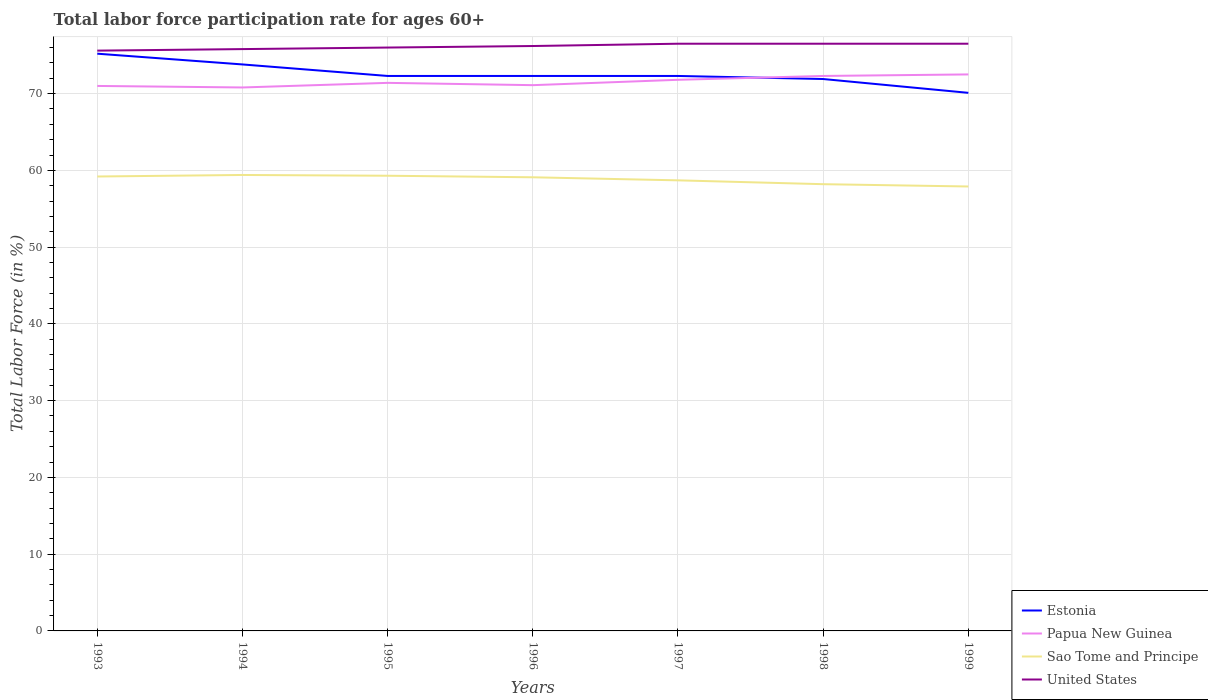How many different coloured lines are there?
Offer a terse response. 4. Is the number of lines equal to the number of legend labels?
Provide a short and direct response. Yes. Across all years, what is the maximum labor force participation rate in Sao Tome and Principe?
Keep it short and to the point. 57.9. In which year was the labor force participation rate in Estonia maximum?
Make the answer very short. 1999. Does the graph contain any zero values?
Keep it short and to the point. No. Does the graph contain grids?
Keep it short and to the point. Yes. How are the legend labels stacked?
Provide a succinct answer. Vertical. What is the title of the graph?
Keep it short and to the point. Total labor force participation rate for ages 60+. What is the label or title of the Y-axis?
Your response must be concise. Total Labor Force (in %). What is the Total Labor Force (in %) in Estonia in 1993?
Offer a terse response. 75.2. What is the Total Labor Force (in %) of Sao Tome and Principe in 1993?
Make the answer very short. 59.2. What is the Total Labor Force (in %) of United States in 1993?
Keep it short and to the point. 75.6. What is the Total Labor Force (in %) of Estonia in 1994?
Your response must be concise. 73.8. What is the Total Labor Force (in %) in Papua New Guinea in 1994?
Your answer should be very brief. 70.8. What is the Total Labor Force (in %) of Sao Tome and Principe in 1994?
Give a very brief answer. 59.4. What is the Total Labor Force (in %) of United States in 1994?
Offer a terse response. 75.8. What is the Total Labor Force (in %) in Estonia in 1995?
Make the answer very short. 72.3. What is the Total Labor Force (in %) of Papua New Guinea in 1995?
Your answer should be very brief. 71.4. What is the Total Labor Force (in %) in Sao Tome and Principe in 1995?
Ensure brevity in your answer.  59.3. What is the Total Labor Force (in %) in United States in 1995?
Provide a short and direct response. 76. What is the Total Labor Force (in %) of Estonia in 1996?
Make the answer very short. 72.3. What is the Total Labor Force (in %) in Papua New Guinea in 1996?
Provide a succinct answer. 71.1. What is the Total Labor Force (in %) of Sao Tome and Principe in 1996?
Ensure brevity in your answer.  59.1. What is the Total Labor Force (in %) in United States in 1996?
Offer a very short reply. 76.2. What is the Total Labor Force (in %) in Estonia in 1997?
Keep it short and to the point. 72.3. What is the Total Labor Force (in %) of Papua New Guinea in 1997?
Keep it short and to the point. 71.8. What is the Total Labor Force (in %) of Sao Tome and Principe in 1997?
Your response must be concise. 58.7. What is the Total Labor Force (in %) in United States in 1997?
Your answer should be very brief. 76.5. What is the Total Labor Force (in %) in Estonia in 1998?
Your answer should be compact. 71.9. What is the Total Labor Force (in %) in Papua New Guinea in 1998?
Give a very brief answer. 72.3. What is the Total Labor Force (in %) of Sao Tome and Principe in 1998?
Offer a terse response. 58.2. What is the Total Labor Force (in %) in United States in 1998?
Keep it short and to the point. 76.5. What is the Total Labor Force (in %) in Estonia in 1999?
Make the answer very short. 70.1. What is the Total Labor Force (in %) of Papua New Guinea in 1999?
Make the answer very short. 72.5. What is the Total Labor Force (in %) in Sao Tome and Principe in 1999?
Give a very brief answer. 57.9. What is the Total Labor Force (in %) in United States in 1999?
Your answer should be very brief. 76.5. Across all years, what is the maximum Total Labor Force (in %) in Estonia?
Ensure brevity in your answer.  75.2. Across all years, what is the maximum Total Labor Force (in %) of Papua New Guinea?
Keep it short and to the point. 72.5. Across all years, what is the maximum Total Labor Force (in %) of Sao Tome and Principe?
Your answer should be very brief. 59.4. Across all years, what is the maximum Total Labor Force (in %) of United States?
Offer a terse response. 76.5. Across all years, what is the minimum Total Labor Force (in %) of Estonia?
Provide a short and direct response. 70.1. Across all years, what is the minimum Total Labor Force (in %) of Papua New Guinea?
Give a very brief answer. 70.8. Across all years, what is the minimum Total Labor Force (in %) of Sao Tome and Principe?
Offer a terse response. 57.9. Across all years, what is the minimum Total Labor Force (in %) in United States?
Keep it short and to the point. 75.6. What is the total Total Labor Force (in %) of Estonia in the graph?
Provide a short and direct response. 507.9. What is the total Total Labor Force (in %) of Papua New Guinea in the graph?
Keep it short and to the point. 500.9. What is the total Total Labor Force (in %) of Sao Tome and Principe in the graph?
Provide a succinct answer. 411.8. What is the total Total Labor Force (in %) in United States in the graph?
Your answer should be very brief. 533.1. What is the difference between the Total Labor Force (in %) in Papua New Guinea in 1993 and that in 1994?
Make the answer very short. 0.2. What is the difference between the Total Labor Force (in %) in Papua New Guinea in 1993 and that in 1996?
Keep it short and to the point. -0.1. What is the difference between the Total Labor Force (in %) in Sao Tome and Principe in 1993 and that in 1996?
Your answer should be very brief. 0.1. What is the difference between the Total Labor Force (in %) of United States in 1993 and that in 1996?
Ensure brevity in your answer.  -0.6. What is the difference between the Total Labor Force (in %) in Sao Tome and Principe in 1993 and that in 1997?
Your answer should be very brief. 0.5. What is the difference between the Total Labor Force (in %) in United States in 1993 and that in 1997?
Your answer should be compact. -0.9. What is the difference between the Total Labor Force (in %) of Sao Tome and Principe in 1993 and that in 1998?
Offer a terse response. 1. What is the difference between the Total Labor Force (in %) of Estonia in 1993 and that in 1999?
Ensure brevity in your answer.  5.1. What is the difference between the Total Labor Force (in %) of Papua New Guinea in 1993 and that in 1999?
Offer a very short reply. -1.5. What is the difference between the Total Labor Force (in %) of United States in 1993 and that in 1999?
Make the answer very short. -0.9. What is the difference between the Total Labor Force (in %) of Estonia in 1994 and that in 1995?
Make the answer very short. 1.5. What is the difference between the Total Labor Force (in %) of Papua New Guinea in 1994 and that in 1995?
Offer a terse response. -0.6. What is the difference between the Total Labor Force (in %) in Sao Tome and Principe in 1994 and that in 1995?
Give a very brief answer. 0.1. What is the difference between the Total Labor Force (in %) of United States in 1994 and that in 1995?
Make the answer very short. -0.2. What is the difference between the Total Labor Force (in %) in Papua New Guinea in 1994 and that in 1996?
Give a very brief answer. -0.3. What is the difference between the Total Labor Force (in %) of Sao Tome and Principe in 1994 and that in 1997?
Offer a very short reply. 0.7. What is the difference between the Total Labor Force (in %) in United States in 1994 and that in 1997?
Your answer should be compact. -0.7. What is the difference between the Total Labor Force (in %) of Papua New Guinea in 1994 and that in 1998?
Keep it short and to the point. -1.5. What is the difference between the Total Labor Force (in %) of United States in 1994 and that in 1998?
Offer a very short reply. -0.7. What is the difference between the Total Labor Force (in %) in Estonia in 1994 and that in 1999?
Offer a very short reply. 3.7. What is the difference between the Total Labor Force (in %) of Papua New Guinea in 1994 and that in 1999?
Make the answer very short. -1.7. What is the difference between the Total Labor Force (in %) in Estonia in 1995 and that in 1996?
Keep it short and to the point. 0. What is the difference between the Total Labor Force (in %) in Papua New Guinea in 1995 and that in 1996?
Offer a terse response. 0.3. What is the difference between the Total Labor Force (in %) of United States in 1995 and that in 1996?
Ensure brevity in your answer.  -0.2. What is the difference between the Total Labor Force (in %) in Estonia in 1995 and that in 1997?
Your response must be concise. 0. What is the difference between the Total Labor Force (in %) in Sao Tome and Principe in 1995 and that in 1997?
Make the answer very short. 0.6. What is the difference between the Total Labor Force (in %) in Papua New Guinea in 1995 and that in 1998?
Your answer should be compact. -0.9. What is the difference between the Total Labor Force (in %) of Sao Tome and Principe in 1995 and that in 1998?
Give a very brief answer. 1.1. What is the difference between the Total Labor Force (in %) of United States in 1995 and that in 1998?
Make the answer very short. -0.5. What is the difference between the Total Labor Force (in %) of Papua New Guinea in 1995 and that in 1999?
Your answer should be compact. -1.1. What is the difference between the Total Labor Force (in %) of Sao Tome and Principe in 1995 and that in 1999?
Keep it short and to the point. 1.4. What is the difference between the Total Labor Force (in %) in Estonia in 1996 and that in 1997?
Give a very brief answer. 0. What is the difference between the Total Labor Force (in %) of United States in 1996 and that in 1997?
Provide a short and direct response. -0.3. What is the difference between the Total Labor Force (in %) of Sao Tome and Principe in 1996 and that in 1998?
Your answer should be compact. 0.9. What is the difference between the Total Labor Force (in %) in United States in 1996 and that in 1998?
Offer a terse response. -0.3. What is the difference between the Total Labor Force (in %) in Estonia in 1996 and that in 1999?
Provide a short and direct response. 2.2. What is the difference between the Total Labor Force (in %) in Estonia in 1997 and that in 1998?
Provide a short and direct response. 0.4. What is the difference between the Total Labor Force (in %) of Papua New Guinea in 1997 and that in 1998?
Offer a terse response. -0.5. What is the difference between the Total Labor Force (in %) of Estonia in 1997 and that in 1999?
Provide a succinct answer. 2.2. What is the difference between the Total Labor Force (in %) of Papua New Guinea in 1997 and that in 1999?
Offer a terse response. -0.7. What is the difference between the Total Labor Force (in %) in Estonia in 1998 and that in 1999?
Your response must be concise. 1.8. What is the difference between the Total Labor Force (in %) in Papua New Guinea in 1998 and that in 1999?
Your response must be concise. -0.2. What is the difference between the Total Labor Force (in %) in United States in 1998 and that in 1999?
Provide a succinct answer. 0. What is the difference between the Total Labor Force (in %) of Papua New Guinea in 1993 and the Total Labor Force (in %) of Sao Tome and Principe in 1994?
Provide a succinct answer. 11.6. What is the difference between the Total Labor Force (in %) of Papua New Guinea in 1993 and the Total Labor Force (in %) of United States in 1994?
Provide a short and direct response. -4.8. What is the difference between the Total Labor Force (in %) in Sao Tome and Principe in 1993 and the Total Labor Force (in %) in United States in 1994?
Make the answer very short. -16.6. What is the difference between the Total Labor Force (in %) of Estonia in 1993 and the Total Labor Force (in %) of Papua New Guinea in 1995?
Your answer should be very brief. 3.8. What is the difference between the Total Labor Force (in %) of Estonia in 1993 and the Total Labor Force (in %) of United States in 1995?
Keep it short and to the point. -0.8. What is the difference between the Total Labor Force (in %) of Papua New Guinea in 1993 and the Total Labor Force (in %) of Sao Tome and Principe in 1995?
Give a very brief answer. 11.7. What is the difference between the Total Labor Force (in %) of Sao Tome and Principe in 1993 and the Total Labor Force (in %) of United States in 1995?
Provide a succinct answer. -16.8. What is the difference between the Total Labor Force (in %) in Estonia in 1993 and the Total Labor Force (in %) in Papua New Guinea in 1996?
Your response must be concise. 4.1. What is the difference between the Total Labor Force (in %) of Estonia in 1993 and the Total Labor Force (in %) of Sao Tome and Principe in 1996?
Offer a terse response. 16.1. What is the difference between the Total Labor Force (in %) in Estonia in 1993 and the Total Labor Force (in %) in United States in 1996?
Make the answer very short. -1. What is the difference between the Total Labor Force (in %) of Papua New Guinea in 1993 and the Total Labor Force (in %) of United States in 1996?
Your answer should be compact. -5.2. What is the difference between the Total Labor Force (in %) of Estonia in 1993 and the Total Labor Force (in %) of Papua New Guinea in 1997?
Make the answer very short. 3.4. What is the difference between the Total Labor Force (in %) of Estonia in 1993 and the Total Labor Force (in %) of Sao Tome and Principe in 1997?
Give a very brief answer. 16.5. What is the difference between the Total Labor Force (in %) of Sao Tome and Principe in 1993 and the Total Labor Force (in %) of United States in 1997?
Your answer should be compact. -17.3. What is the difference between the Total Labor Force (in %) in Estonia in 1993 and the Total Labor Force (in %) in Papua New Guinea in 1998?
Provide a succinct answer. 2.9. What is the difference between the Total Labor Force (in %) of Estonia in 1993 and the Total Labor Force (in %) of Sao Tome and Principe in 1998?
Provide a succinct answer. 17. What is the difference between the Total Labor Force (in %) in Estonia in 1993 and the Total Labor Force (in %) in United States in 1998?
Provide a succinct answer. -1.3. What is the difference between the Total Labor Force (in %) in Papua New Guinea in 1993 and the Total Labor Force (in %) in United States in 1998?
Keep it short and to the point. -5.5. What is the difference between the Total Labor Force (in %) in Sao Tome and Principe in 1993 and the Total Labor Force (in %) in United States in 1998?
Your answer should be compact. -17.3. What is the difference between the Total Labor Force (in %) in Estonia in 1993 and the Total Labor Force (in %) in Papua New Guinea in 1999?
Your answer should be compact. 2.7. What is the difference between the Total Labor Force (in %) of Papua New Guinea in 1993 and the Total Labor Force (in %) of United States in 1999?
Give a very brief answer. -5.5. What is the difference between the Total Labor Force (in %) in Sao Tome and Principe in 1993 and the Total Labor Force (in %) in United States in 1999?
Offer a terse response. -17.3. What is the difference between the Total Labor Force (in %) in Estonia in 1994 and the Total Labor Force (in %) in Papua New Guinea in 1995?
Provide a succinct answer. 2.4. What is the difference between the Total Labor Force (in %) of Estonia in 1994 and the Total Labor Force (in %) of Sao Tome and Principe in 1995?
Provide a short and direct response. 14.5. What is the difference between the Total Labor Force (in %) in Papua New Guinea in 1994 and the Total Labor Force (in %) in United States in 1995?
Provide a succinct answer. -5.2. What is the difference between the Total Labor Force (in %) in Sao Tome and Principe in 1994 and the Total Labor Force (in %) in United States in 1995?
Your answer should be compact. -16.6. What is the difference between the Total Labor Force (in %) in Estonia in 1994 and the Total Labor Force (in %) in Sao Tome and Principe in 1996?
Make the answer very short. 14.7. What is the difference between the Total Labor Force (in %) of Sao Tome and Principe in 1994 and the Total Labor Force (in %) of United States in 1996?
Give a very brief answer. -16.8. What is the difference between the Total Labor Force (in %) of Estonia in 1994 and the Total Labor Force (in %) of United States in 1997?
Provide a succinct answer. -2.7. What is the difference between the Total Labor Force (in %) in Papua New Guinea in 1994 and the Total Labor Force (in %) in United States in 1997?
Provide a succinct answer. -5.7. What is the difference between the Total Labor Force (in %) of Sao Tome and Principe in 1994 and the Total Labor Force (in %) of United States in 1997?
Ensure brevity in your answer.  -17.1. What is the difference between the Total Labor Force (in %) in Estonia in 1994 and the Total Labor Force (in %) in United States in 1998?
Offer a terse response. -2.7. What is the difference between the Total Labor Force (in %) in Papua New Guinea in 1994 and the Total Labor Force (in %) in United States in 1998?
Your answer should be very brief. -5.7. What is the difference between the Total Labor Force (in %) in Sao Tome and Principe in 1994 and the Total Labor Force (in %) in United States in 1998?
Your answer should be very brief. -17.1. What is the difference between the Total Labor Force (in %) in Estonia in 1994 and the Total Labor Force (in %) in Papua New Guinea in 1999?
Provide a short and direct response. 1.3. What is the difference between the Total Labor Force (in %) of Estonia in 1994 and the Total Labor Force (in %) of United States in 1999?
Ensure brevity in your answer.  -2.7. What is the difference between the Total Labor Force (in %) in Papua New Guinea in 1994 and the Total Labor Force (in %) in United States in 1999?
Your answer should be very brief. -5.7. What is the difference between the Total Labor Force (in %) of Sao Tome and Principe in 1994 and the Total Labor Force (in %) of United States in 1999?
Offer a terse response. -17.1. What is the difference between the Total Labor Force (in %) in Estonia in 1995 and the Total Labor Force (in %) in Papua New Guinea in 1996?
Offer a very short reply. 1.2. What is the difference between the Total Labor Force (in %) of Estonia in 1995 and the Total Labor Force (in %) of Sao Tome and Principe in 1996?
Ensure brevity in your answer.  13.2. What is the difference between the Total Labor Force (in %) of Estonia in 1995 and the Total Labor Force (in %) of United States in 1996?
Your answer should be compact. -3.9. What is the difference between the Total Labor Force (in %) in Sao Tome and Principe in 1995 and the Total Labor Force (in %) in United States in 1996?
Provide a short and direct response. -16.9. What is the difference between the Total Labor Force (in %) of Estonia in 1995 and the Total Labor Force (in %) of Papua New Guinea in 1997?
Provide a short and direct response. 0.5. What is the difference between the Total Labor Force (in %) in Papua New Guinea in 1995 and the Total Labor Force (in %) in Sao Tome and Principe in 1997?
Give a very brief answer. 12.7. What is the difference between the Total Labor Force (in %) of Sao Tome and Principe in 1995 and the Total Labor Force (in %) of United States in 1997?
Offer a terse response. -17.2. What is the difference between the Total Labor Force (in %) in Estonia in 1995 and the Total Labor Force (in %) in Papua New Guinea in 1998?
Your response must be concise. 0. What is the difference between the Total Labor Force (in %) in Estonia in 1995 and the Total Labor Force (in %) in United States in 1998?
Keep it short and to the point. -4.2. What is the difference between the Total Labor Force (in %) in Papua New Guinea in 1995 and the Total Labor Force (in %) in Sao Tome and Principe in 1998?
Offer a very short reply. 13.2. What is the difference between the Total Labor Force (in %) of Sao Tome and Principe in 1995 and the Total Labor Force (in %) of United States in 1998?
Your response must be concise. -17.2. What is the difference between the Total Labor Force (in %) in Estonia in 1995 and the Total Labor Force (in %) in Sao Tome and Principe in 1999?
Keep it short and to the point. 14.4. What is the difference between the Total Labor Force (in %) of Papua New Guinea in 1995 and the Total Labor Force (in %) of Sao Tome and Principe in 1999?
Ensure brevity in your answer.  13.5. What is the difference between the Total Labor Force (in %) in Sao Tome and Principe in 1995 and the Total Labor Force (in %) in United States in 1999?
Provide a short and direct response. -17.2. What is the difference between the Total Labor Force (in %) of Estonia in 1996 and the Total Labor Force (in %) of Sao Tome and Principe in 1997?
Your answer should be very brief. 13.6. What is the difference between the Total Labor Force (in %) in Papua New Guinea in 1996 and the Total Labor Force (in %) in Sao Tome and Principe in 1997?
Give a very brief answer. 12.4. What is the difference between the Total Labor Force (in %) of Sao Tome and Principe in 1996 and the Total Labor Force (in %) of United States in 1997?
Ensure brevity in your answer.  -17.4. What is the difference between the Total Labor Force (in %) in Estonia in 1996 and the Total Labor Force (in %) in Papua New Guinea in 1998?
Offer a terse response. 0. What is the difference between the Total Labor Force (in %) of Estonia in 1996 and the Total Labor Force (in %) of Sao Tome and Principe in 1998?
Give a very brief answer. 14.1. What is the difference between the Total Labor Force (in %) of Papua New Guinea in 1996 and the Total Labor Force (in %) of Sao Tome and Principe in 1998?
Offer a terse response. 12.9. What is the difference between the Total Labor Force (in %) of Sao Tome and Principe in 1996 and the Total Labor Force (in %) of United States in 1998?
Keep it short and to the point. -17.4. What is the difference between the Total Labor Force (in %) of Papua New Guinea in 1996 and the Total Labor Force (in %) of United States in 1999?
Make the answer very short. -5.4. What is the difference between the Total Labor Force (in %) of Sao Tome and Principe in 1996 and the Total Labor Force (in %) of United States in 1999?
Make the answer very short. -17.4. What is the difference between the Total Labor Force (in %) in Estonia in 1997 and the Total Labor Force (in %) in Sao Tome and Principe in 1998?
Provide a succinct answer. 14.1. What is the difference between the Total Labor Force (in %) of Sao Tome and Principe in 1997 and the Total Labor Force (in %) of United States in 1998?
Provide a short and direct response. -17.8. What is the difference between the Total Labor Force (in %) in Estonia in 1997 and the Total Labor Force (in %) in Sao Tome and Principe in 1999?
Your answer should be compact. 14.4. What is the difference between the Total Labor Force (in %) of Estonia in 1997 and the Total Labor Force (in %) of United States in 1999?
Offer a very short reply. -4.2. What is the difference between the Total Labor Force (in %) in Papua New Guinea in 1997 and the Total Labor Force (in %) in Sao Tome and Principe in 1999?
Ensure brevity in your answer.  13.9. What is the difference between the Total Labor Force (in %) in Papua New Guinea in 1997 and the Total Labor Force (in %) in United States in 1999?
Your response must be concise. -4.7. What is the difference between the Total Labor Force (in %) of Sao Tome and Principe in 1997 and the Total Labor Force (in %) of United States in 1999?
Your answer should be very brief. -17.8. What is the difference between the Total Labor Force (in %) of Estonia in 1998 and the Total Labor Force (in %) of Papua New Guinea in 1999?
Offer a very short reply. -0.6. What is the difference between the Total Labor Force (in %) of Papua New Guinea in 1998 and the Total Labor Force (in %) of Sao Tome and Principe in 1999?
Your response must be concise. 14.4. What is the difference between the Total Labor Force (in %) in Papua New Guinea in 1998 and the Total Labor Force (in %) in United States in 1999?
Offer a very short reply. -4.2. What is the difference between the Total Labor Force (in %) in Sao Tome and Principe in 1998 and the Total Labor Force (in %) in United States in 1999?
Provide a short and direct response. -18.3. What is the average Total Labor Force (in %) in Estonia per year?
Provide a succinct answer. 72.56. What is the average Total Labor Force (in %) in Papua New Guinea per year?
Provide a succinct answer. 71.56. What is the average Total Labor Force (in %) in Sao Tome and Principe per year?
Make the answer very short. 58.83. What is the average Total Labor Force (in %) in United States per year?
Keep it short and to the point. 76.16. In the year 1993, what is the difference between the Total Labor Force (in %) in Estonia and Total Labor Force (in %) in Sao Tome and Principe?
Provide a short and direct response. 16. In the year 1993, what is the difference between the Total Labor Force (in %) in Papua New Guinea and Total Labor Force (in %) in Sao Tome and Principe?
Offer a terse response. 11.8. In the year 1993, what is the difference between the Total Labor Force (in %) in Papua New Guinea and Total Labor Force (in %) in United States?
Your answer should be very brief. -4.6. In the year 1993, what is the difference between the Total Labor Force (in %) in Sao Tome and Principe and Total Labor Force (in %) in United States?
Give a very brief answer. -16.4. In the year 1994, what is the difference between the Total Labor Force (in %) in Estonia and Total Labor Force (in %) in Papua New Guinea?
Make the answer very short. 3. In the year 1994, what is the difference between the Total Labor Force (in %) of Papua New Guinea and Total Labor Force (in %) of Sao Tome and Principe?
Keep it short and to the point. 11.4. In the year 1994, what is the difference between the Total Labor Force (in %) in Sao Tome and Principe and Total Labor Force (in %) in United States?
Your answer should be compact. -16.4. In the year 1995, what is the difference between the Total Labor Force (in %) of Papua New Guinea and Total Labor Force (in %) of United States?
Make the answer very short. -4.6. In the year 1995, what is the difference between the Total Labor Force (in %) of Sao Tome and Principe and Total Labor Force (in %) of United States?
Give a very brief answer. -16.7. In the year 1996, what is the difference between the Total Labor Force (in %) of Estonia and Total Labor Force (in %) of Papua New Guinea?
Offer a terse response. 1.2. In the year 1996, what is the difference between the Total Labor Force (in %) of Estonia and Total Labor Force (in %) of United States?
Provide a succinct answer. -3.9. In the year 1996, what is the difference between the Total Labor Force (in %) in Papua New Guinea and Total Labor Force (in %) in Sao Tome and Principe?
Make the answer very short. 12. In the year 1996, what is the difference between the Total Labor Force (in %) in Sao Tome and Principe and Total Labor Force (in %) in United States?
Offer a very short reply. -17.1. In the year 1997, what is the difference between the Total Labor Force (in %) of Estonia and Total Labor Force (in %) of Papua New Guinea?
Your answer should be very brief. 0.5. In the year 1997, what is the difference between the Total Labor Force (in %) of Estonia and Total Labor Force (in %) of Sao Tome and Principe?
Your response must be concise. 13.6. In the year 1997, what is the difference between the Total Labor Force (in %) of Estonia and Total Labor Force (in %) of United States?
Offer a very short reply. -4.2. In the year 1997, what is the difference between the Total Labor Force (in %) of Papua New Guinea and Total Labor Force (in %) of United States?
Offer a very short reply. -4.7. In the year 1997, what is the difference between the Total Labor Force (in %) of Sao Tome and Principe and Total Labor Force (in %) of United States?
Give a very brief answer. -17.8. In the year 1998, what is the difference between the Total Labor Force (in %) of Estonia and Total Labor Force (in %) of Papua New Guinea?
Ensure brevity in your answer.  -0.4. In the year 1998, what is the difference between the Total Labor Force (in %) of Estonia and Total Labor Force (in %) of Sao Tome and Principe?
Offer a very short reply. 13.7. In the year 1998, what is the difference between the Total Labor Force (in %) of Papua New Guinea and Total Labor Force (in %) of Sao Tome and Principe?
Give a very brief answer. 14.1. In the year 1998, what is the difference between the Total Labor Force (in %) of Papua New Guinea and Total Labor Force (in %) of United States?
Give a very brief answer. -4.2. In the year 1998, what is the difference between the Total Labor Force (in %) of Sao Tome and Principe and Total Labor Force (in %) of United States?
Offer a terse response. -18.3. In the year 1999, what is the difference between the Total Labor Force (in %) of Estonia and Total Labor Force (in %) of Sao Tome and Principe?
Offer a very short reply. 12.2. In the year 1999, what is the difference between the Total Labor Force (in %) of Papua New Guinea and Total Labor Force (in %) of Sao Tome and Principe?
Your answer should be very brief. 14.6. In the year 1999, what is the difference between the Total Labor Force (in %) of Sao Tome and Principe and Total Labor Force (in %) of United States?
Provide a succinct answer. -18.6. What is the ratio of the Total Labor Force (in %) of Papua New Guinea in 1993 to that in 1994?
Offer a terse response. 1. What is the ratio of the Total Labor Force (in %) of Sao Tome and Principe in 1993 to that in 1994?
Keep it short and to the point. 1. What is the ratio of the Total Labor Force (in %) of United States in 1993 to that in 1994?
Provide a short and direct response. 1. What is the ratio of the Total Labor Force (in %) in Estonia in 1993 to that in 1995?
Your answer should be compact. 1.04. What is the ratio of the Total Labor Force (in %) in Sao Tome and Principe in 1993 to that in 1995?
Give a very brief answer. 1. What is the ratio of the Total Labor Force (in %) in Estonia in 1993 to that in 1996?
Offer a terse response. 1.04. What is the ratio of the Total Labor Force (in %) of Papua New Guinea in 1993 to that in 1996?
Offer a terse response. 1. What is the ratio of the Total Labor Force (in %) in Estonia in 1993 to that in 1997?
Provide a succinct answer. 1.04. What is the ratio of the Total Labor Force (in %) of Papua New Guinea in 1993 to that in 1997?
Your answer should be very brief. 0.99. What is the ratio of the Total Labor Force (in %) of Sao Tome and Principe in 1993 to that in 1997?
Provide a short and direct response. 1.01. What is the ratio of the Total Labor Force (in %) of United States in 1993 to that in 1997?
Offer a terse response. 0.99. What is the ratio of the Total Labor Force (in %) of Estonia in 1993 to that in 1998?
Your answer should be compact. 1.05. What is the ratio of the Total Labor Force (in %) of Papua New Guinea in 1993 to that in 1998?
Offer a very short reply. 0.98. What is the ratio of the Total Labor Force (in %) of Sao Tome and Principe in 1993 to that in 1998?
Provide a succinct answer. 1.02. What is the ratio of the Total Labor Force (in %) of Estonia in 1993 to that in 1999?
Give a very brief answer. 1.07. What is the ratio of the Total Labor Force (in %) of Papua New Guinea in 1993 to that in 1999?
Offer a very short reply. 0.98. What is the ratio of the Total Labor Force (in %) in Sao Tome and Principe in 1993 to that in 1999?
Offer a terse response. 1.02. What is the ratio of the Total Labor Force (in %) in United States in 1993 to that in 1999?
Make the answer very short. 0.99. What is the ratio of the Total Labor Force (in %) of Estonia in 1994 to that in 1995?
Keep it short and to the point. 1.02. What is the ratio of the Total Labor Force (in %) in Estonia in 1994 to that in 1996?
Make the answer very short. 1.02. What is the ratio of the Total Labor Force (in %) in Papua New Guinea in 1994 to that in 1996?
Make the answer very short. 1. What is the ratio of the Total Labor Force (in %) in United States in 1994 to that in 1996?
Make the answer very short. 0.99. What is the ratio of the Total Labor Force (in %) of Estonia in 1994 to that in 1997?
Give a very brief answer. 1.02. What is the ratio of the Total Labor Force (in %) in Papua New Guinea in 1994 to that in 1997?
Your answer should be very brief. 0.99. What is the ratio of the Total Labor Force (in %) in Sao Tome and Principe in 1994 to that in 1997?
Ensure brevity in your answer.  1.01. What is the ratio of the Total Labor Force (in %) of Estonia in 1994 to that in 1998?
Your response must be concise. 1.03. What is the ratio of the Total Labor Force (in %) of Papua New Guinea in 1994 to that in 1998?
Provide a short and direct response. 0.98. What is the ratio of the Total Labor Force (in %) of Sao Tome and Principe in 1994 to that in 1998?
Your answer should be very brief. 1.02. What is the ratio of the Total Labor Force (in %) in United States in 1994 to that in 1998?
Offer a very short reply. 0.99. What is the ratio of the Total Labor Force (in %) of Estonia in 1994 to that in 1999?
Keep it short and to the point. 1.05. What is the ratio of the Total Labor Force (in %) of Papua New Guinea in 1994 to that in 1999?
Offer a terse response. 0.98. What is the ratio of the Total Labor Force (in %) of Sao Tome and Principe in 1994 to that in 1999?
Your response must be concise. 1.03. What is the ratio of the Total Labor Force (in %) of United States in 1994 to that in 1999?
Your answer should be compact. 0.99. What is the ratio of the Total Labor Force (in %) of Estonia in 1995 to that in 1996?
Ensure brevity in your answer.  1. What is the ratio of the Total Labor Force (in %) of Papua New Guinea in 1995 to that in 1996?
Keep it short and to the point. 1. What is the ratio of the Total Labor Force (in %) in United States in 1995 to that in 1996?
Your response must be concise. 1. What is the ratio of the Total Labor Force (in %) in Estonia in 1995 to that in 1997?
Offer a very short reply. 1. What is the ratio of the Total Labor Force (in %) of Papua New Guinea in 1995 to that in 1997?
Your answer should be very brief. 0.99. What is the ratio of the Total Labor Force (in %) of Sao Tome and Principe in 1995 to that in 1997?
Provide a succinct answer. 1.01. What is the ratio of the Total Labor Force (in %) of Estonia in 1995 to that in 1998?
Provide a short and direct response. 1.01. What is the ratio of the Total Labor Force (in %) of Papua New Guinea in 1995 to that in 1998?
Offer a very short reply. 0.99. What is the ratio of the Total Labor Force (in %) of Sao Tome and Principe in 1995 to that in 1998?
Your answer should be compact. 1.02. What is the ratio of the Total Labor Force (in %) of Estonia in 1995 to that in 1999?
Offer a very short reply. 1.03. What is the ratio of the Total Labor Force (in %) in Papua New Guinea in 1995 to that in 1999?
Keep it short and to the point. 0.98. What is the ratio of the Total Labor Force (in %) of Sao Tome and Principe in 1995 to that in 1999?
Keep it short and to the point. 1.02. What is the ratio of the Total Labor Force (in %) in Papua New Guinea in 1996 to that in 1997?
Give a very brief answer. 0.99. What is the ratio of the Total Labor Force (in %) in Sao Tome and Principe in 1996 to that in 1997?
Offer a terse response. 1.01. What is the ratio of the Total Labor Force (in %) in United States in 1996 to that in 1997?
Make the answer very short. 1. What is the ratio of the Total Labor Force (in %) of Estonia in 1996 to that in 1998?
Keep it short and to the point. 1.01. What is the ratio of the Total Labor Force (in %) in Papua New Guinea in 1996 to that in 1998?
Ensure brevity in your answer.  0.98. What is the ratio of the Total Labor Force (in %) of Sao Tome and Principe in 1996 to that in 1998?
Give a very brief answer. 1.02. What is the ratio of the Total Labor Force (in %) of Estonia in 1996 to that in 1999?
Ensure brevity in your answer.  1.03. What is the ratio of the Total Labor Force (in %) in Papua New Guinea in 1996 to that in 1999?
Give a very brief answer. 0.98. What is the ratio of the Total Labor Force (in %) of Sao Tome and Principe in 1996 to that in 1999?
Your answer should be compact. 1.02. What is the ratio of the Total Labor Force (in %) in Estonia in 1997 to that in 1998?
Your response must be concise. 1.01. What is the ratio of the Total Labor Force (in %) in Sao Tome and Principe in 1997 to that in 1998?
Provide a succinct answer. 1.01. What is the ratio of the Total Labor Force (in %) of United States in 1997 to that in 1998?
Keep it short and to the point. 1. What is the ratio of the Total Labor Force (in %) of Estonia in 1997 to that in 1999?
Offer a very short reply. 1.03. What is the ratio of the Total Labor Force (in %) in Papua New Guinea in 1997 to that in 1999?
Provide a short and direct response. 0.99. What is the ratio of the Total Labor Force (in %) in Sao Tome and Principe in 1997 to that in 1999?
Give a very brief answer. 1.01. What is the ratio of the Total Labor Force (in %) of Estonia in 1998 to that in 1999?
Your response must be concise. 1.03. What is the ratio of the Total Labor Force (in %) of Sao Tome and Principe in 1998 to that in 1999?
Make the answer very short. 1.01. What is the difference between the highest and the second highest Total Labor Force (in %) of Papua New Guinea?
Give a very brief answer. 0.2. What is the difference between the highest and the second highest Total Labor Force (in %) of Sao Tome and Principe?
Offer a very short reply. 0.1. What is the difference between the highest and the lowest Total Labor Force (in %) in United States?
Your response must be concise. 0.9. 